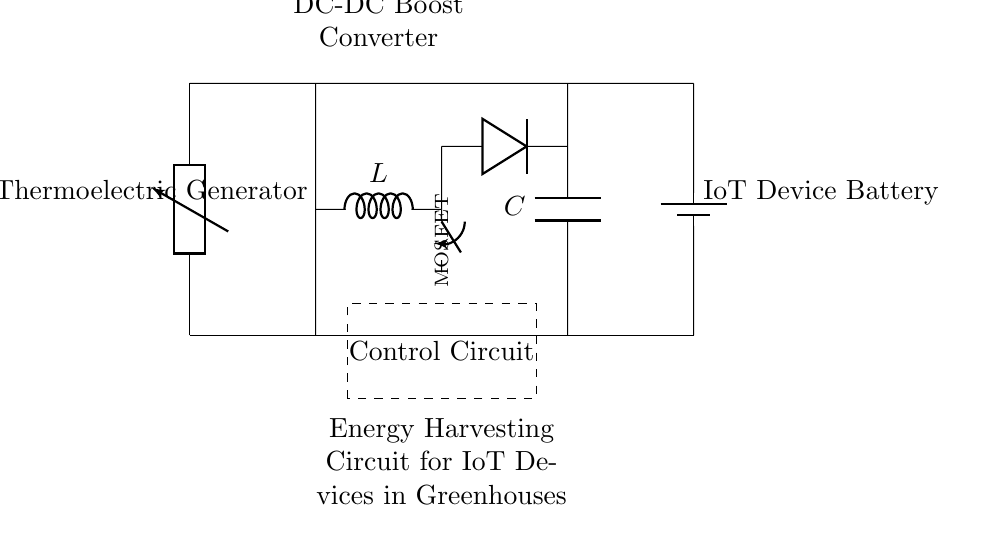What is the primary component used for energy harvesting in this circuit? The primary component for energy harvesting is the thermoelectric generator, as it converts temperature differentials into electrical energy.
Answer: thermoelectric generator What type of converter is used in this circuit? The circuit employs a DC-DC boost converter, which steps up the voltage to a suitable level for charging purposes.
Answer: DC-DC boost converter How many passive components are present in the circuit? The circuit has three passive components: one inductor, one capacitor, and one MOSFET (considered as a discrete device here).
Answer: three What is the role of the diode in this circuit? The diode prevents backflow of current, ensuring that the energy harvested from the thermoelectric generator can only flow in one direction towards the battery.
Answer: Prevents backflow What is the purpose of the control circuit shown in the diagram? The control circuit regulates the charging process and manages the operation of the DC-DC converter to optimize the charging of the IoT device battery.
Answer: Regulates charging How does the energy source in this circuit work? The thermoelectric generator works by converting temperature differentials into electrical energy, typically leveraging the heat variation inside the greenhouse.
Answer: Converts temperature differentials 